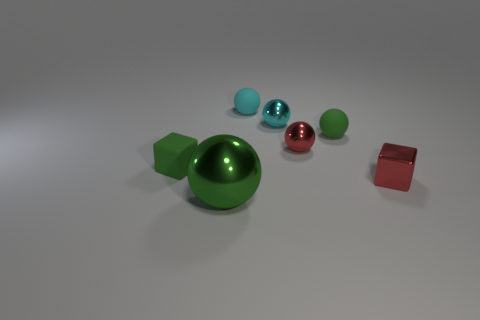There is a thing left of the large object; is it the same shape as the green matte object right of the large thing?
Your response must be concise. No. Are there the same number of green matte things right of the big ball and big yellow rubber blocks?
Make the answer very short. No. Are there any other things that have the same size as the cyan rubber sphere?
Provide a succinct answer. Yes. There is another green object that is the same shape as the big thing; what material is it?
Provide a succinct answer. Rubber. What is the shape of the large object that is in front of the tiny cyan rubber object that is on the left side of the tiny cyan metal object?
Give a very brief answer. Sphere. Does the green thing that is on the right side of the small cyan metal thing have the same material as the tiny green block?
Your answer should be very brief. Yes. Is the number of green metallic things that are on the left side of the small green block the same as the number of small metal spheres in front of the small metallic cube?
Your answer should be very brief. Yes. What material is the small sphere that is the same color as the tiny metallic cube?
Give a very brief answer. Metal. There is a tiny green matte object that is to the right of the large thing; what number of green cubes are in front of it?
Ensure brevity in your answer.  1. There is a cube that is in front of the green matte block; is it the same color as the tiny rubber object on the left side of the cyan rubber thing?
Make the answer very short. No. 